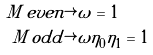<formula> <loc_0><loc_0><loc_500><loc_500>M \, e v e n & \rightarrow \tilde { \omega } = 1 \\ M \, o d d & \rightarrow \tilde { \omega } \eta _ { 0 } \eta _ { 1 } = 1</formula> 